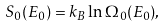<formula> <loc_0><loc_0><loc_500><loc_500>S _ { 0 } ( E _ { 0 } ) = k _ { B } \ln \Omega _ { 0 } ( E _ { 0 } ) ,</formula> 